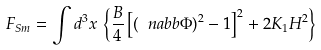Convert formula to latex. <formula><loc_0><loc_0><loc_500><loc_500>F _ { S m } = \int d ^ { 3 } x \, \left \{ \frac { B } { 4 } \left [ \left ( \ n a b b \Phi \right ) ^ { 2 } - 1 \right ] ^ { 2 } + 2 K _ { 1 } H ^ { 2 } \right \}</formula> 